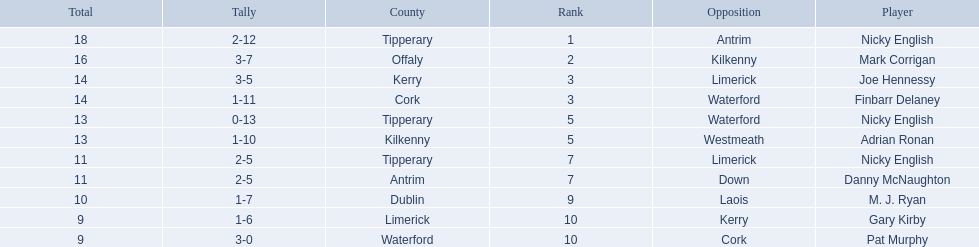Who are all the players? Nicky English, Mark Corrigan, Joe Hennessy, Finbarr Delaney, Nicky English, Adrian Ronan, Nicky English, Danny McNaughton, M. J. Ryan, Gary Kirby, Pat Murphy. How many points did they receive? 18, 16, 14, 14, 13, 13, 11, 11, 10, 9, 9. And which player received 10 points? M. J. Ryan. 